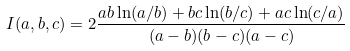Convert formula to latex. <formula><loc_0><loc_0><loc_500><loc_500>I ( a , b , c ) = 2 { \frac { a b \ln ( a / b ) + b c \ln ( b / c ) + a c \ln ( c / a ) } { ( a - b ) ( b - c ) ( a - c ) } } \,</formula> 